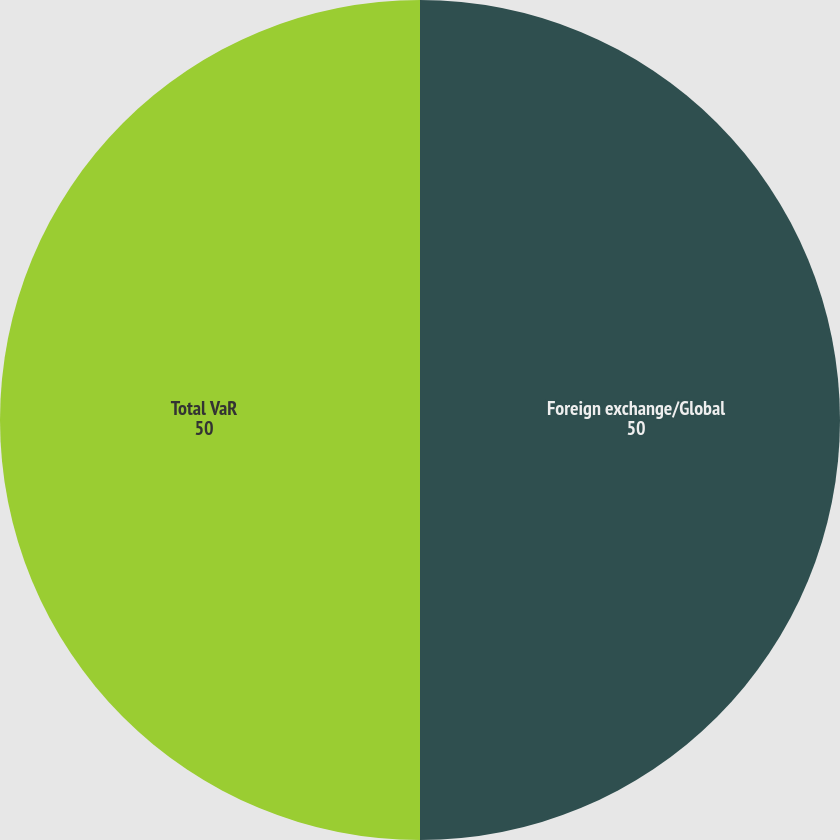<chart> <loc_0><loc_0><loc_500><loc_500><pie_chart><fcel>Foreign exchange/Global<fcel>Total VaR<nl><fcel>50.0%<fcel>50.0%<nl></chart> 